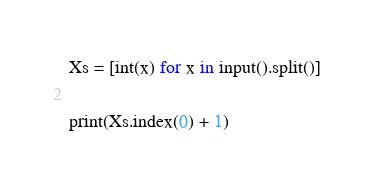<code> <loc_0><loc_0><loc_500><loc_500><_Python_>Xs = [int(x) for x in input().split()]

print(Xs.index(0) + 1)</code> 